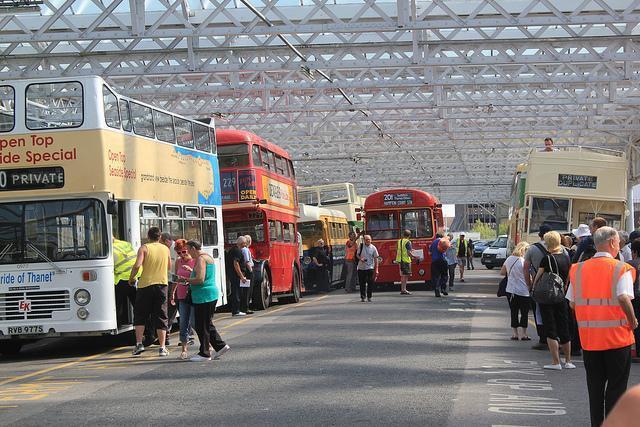How many people can be seen?
Give a very brief answer. 5. How many buses can be seen?
Give a very brief answer. 5. How many keyboards are visible?
Give a very brief answer. 0. 